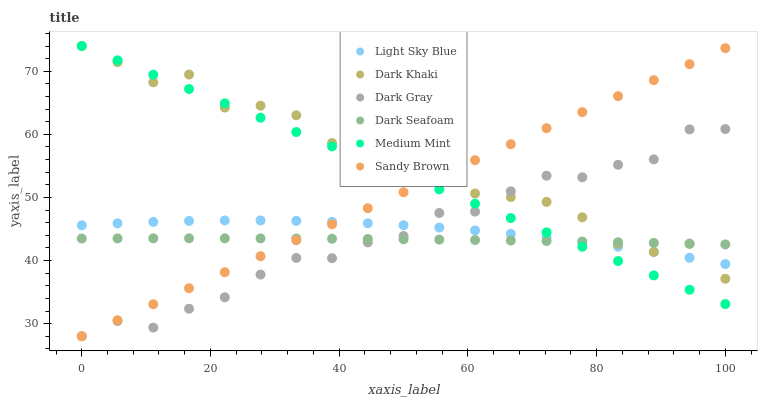Does Dark Seafoam have the minimum area under the curve?
Answer yes or no. Yes. Does Dark Khaki have the maximum area under the curve?
Answer yes or no. Yes. Does Dark Gray have the minimum area under the curve?
Answer yes or no. No. Does Dark Gray have the maximum area under the curve?
Answer yes or no. No. Is Sandy Brown the smoothest?
Answer yes or no. Yes. Is Dark Khaki the roughest?
Answer yes or no. Yes. Is Dark Gray the smoothest?
Answer yes or no. No. Is Dark Gray the roughest?
Answer yes or no. No. Does Dark Gray have the lowest value?
Answer yes or no. Yes. Does Dark Khaki have the lowest value?
Answer yes or no. No. Does Dark Khaki have the highest value?
Answer yes or no. Yes. Does Dark Gray have the highest value?
Answer yes or no. No. Does Dark Khaki intersect Light Sky Blue?
Answer yes or no. Yes. Is Dark Khaki less than Light Sky Blue?
Answer yes or no. No. Is Dark Khaki greater than Light Sky Blue?
Answer yes or no. No. 